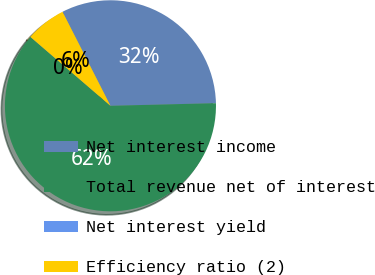<chart> <loc_0><loc_0><loc_500><loc_500><pie_chart><fcel>Net interest income<fcel>Total revenue net of interest<fcel>Net interest yield<fcel>Efficiency ratio (2)<nl><fcel>32.11%<fcel>61.7%<fcel>0.01%<fcel>6.18%<nl></chart> 